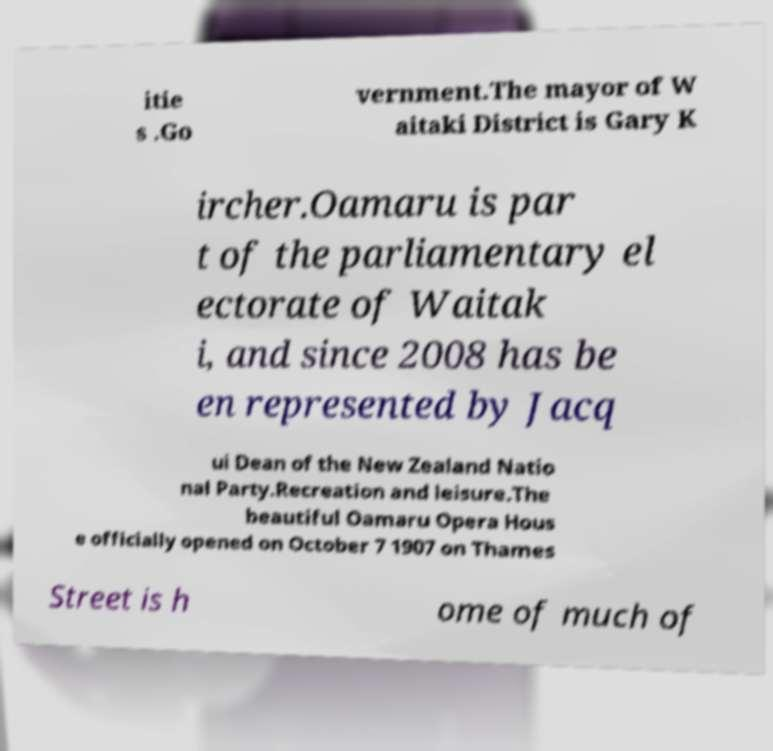Could you assist in decoding the text presented in this image and type it out clearly? itie s .Go vernment.The mayor of W aitaki District is Gary K ircher.Oamaru is par t of the parliamentary el ectorate of Waitak i, and since 2008 has be en represented by Jacq ui Dean of the New Zealand Natio nal Party.Recreation and leisure.The beautiful Oamaru Opera Hous e officially opened on October 7 1907 on Thames Street is h ome of much of 